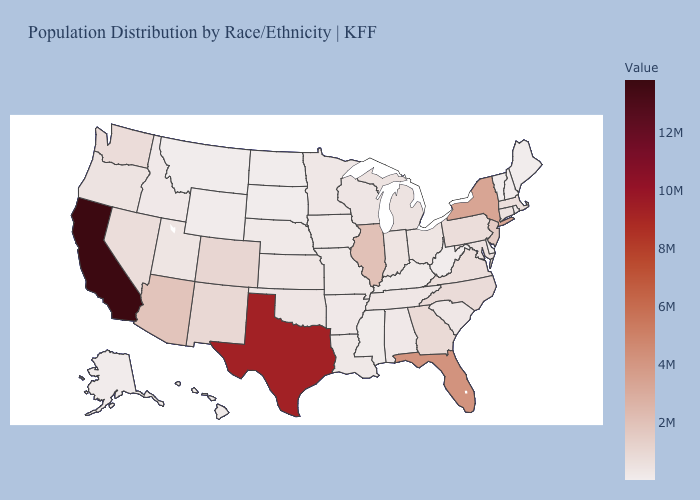Among the states that border Wyoming , does Colorado have the highest value?
Be succinct. Yes. Which states have the lowest value in the MidWest?
Write a very short answer. North Dakota. Among the states that border Wyoming , which have the highest value?
Quick response, please. Colorado. Does South Carolina have a higher value than Texas?
Give a very brief answer. No. 